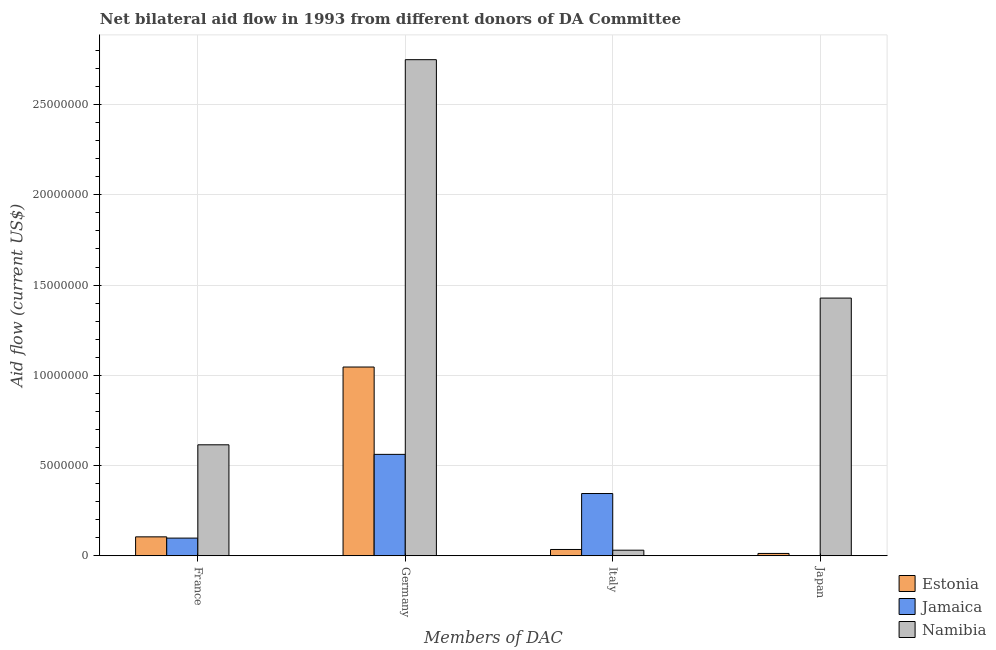How many different coloured bars are there?
Provide a short and direct response. 3. Are the number of bars per tick equal to the number of legend labels?
Offer a very short reply. No. Are the number of bars on each tick of the X-axis equal?
Your response must be concise. No. How many bars are there on the 2nd tick from the left?
Provide a succinct answer. 3. How many bars are there on the 1st tick from the right?
Ensure brevity in your answer.  2. What is the label of the 2nd group of bars from the left?
Your response must be concise. Germany. What is the amount of aid given by germany in Namibia?
Your response must be concise. 2.75e+07. Across all countries, what is the maximum amount of aid given by france?
Provide a succinct answer. 6.15e+06. Across all countries, what is the minimum amount of aid given by france?
Your response must be concise. 9.80e+05. In which country was the amount of aid given by japan maximum?
Your answer should be compact. Namibia. What is the total amount of aid given by germany in the graph?
Your answer should be very brief. 4.36e+07. What is the difference between the amount of aid given by france in Jamaica and that in Estonia?
Ensure brevity in your answer.  -7.00e+04. What is the difference between the amount of aid given by japan in Jamaica and the amount of aid given by germany in Estonia?
Provide a succinct answer. -1.05e+07. What is the average amount of aid given by france per country?
Make the answer very short. 2.73e+06. What is the difference between the amount of aid given by germany and amount of aid given by italy in Namibia?
Provide a short and direct response. 2.72e+07. In how many countries, is the amount of aid given by japan greater than 19000000 US$?
Keep it short and to the point. 0. What is the ratio of the amount of aid given by germany in Namibia to that in Estonia?
Keep it short and to the point. 2.63. Is the difference between the amount of aid given by italy in Jamaica and Namibia greater than the difference between the amount of aid given by france in Jamaica and Namibia?
Provide a short and direct response. Yes. What is the difference between the highest and the second highest amount of aid given by germany?
Your response must be concise. 1.70e+07. What is the difference between the highest and the lowest amount of aid given by france?
Provide a short and direct response. 5.17e+06. How many bars are there?
Provide a short and direct response. 11. How many countries are there in the graph?
Provide a succinct answer. 3. Does the graph contain any zero values?
Give a very brief answer. Yes. Does the graph contain grids?
Offer a very short reply. Yes. Where does the legend appear in the graph?
Your response must be concise. Bottom right. How many legend labels are there?
Provide a succinct answer. 3. How are the legend labels stacked?
Provide a short and direct response. Vertical. What is the title of the graph?
Give a very brief answer. Net bilateral aid flow in 1993 from different donors of DA Committee. Does "High income: nonOECD" appear as one of the legend labels in the graph?
Ensure brevity in your answer.  No. What is the label or title of the X-axis?
Your answer should be very brief. Members of DAC. What is the Aid flow (current US$) in Estonia in France?
Your response must be concise. 1.05e+06. What is the Aid flow (current US$) of Jamaica in France?
Provide a short and direct response. 9.80e+05. What is the Aid flow (current US$) of Namibia in France?
Offer a very short reply. 6.15e+06. What is the Aid flow (current US$) of Estonia in Germany?
Your answer should be compact. 1.05e+07. What is the Aid flow (current US$) of Jamaica in Germany?
Provide a succinct answer. 5.62e+06. What is the Aid flow (current US$) of Namibia in Germany?
Your answer should be compact. 2.75e+07. What is the Aid flow (current US$) in Jamaica in Italy?
Make the answer very short. 3.45e+06. What is the Aid flow (current US$) in Jamaica in Japan?
Your response must be concise. 0. What is the Aid flow (current US$) in Namibia in Japan?
Your answer should be very brief. 1.43e+07. Across all Members of DAC, what is the maximum Aid flow (current US$) of Estonia?
Your response must be concise. 1.05e+07. Across all Members of DAC, what is the maximum Aid flow (current US$) in Jamaica?
Your response must be concise. 5.62e+06. Across all Members of DAC, what is the maximum Aid flow (current US$) of Namibia?
Provide a succinct answer. 2.75e+07. Across all Members of DAC, what is the minimum Aid flow (current US$) of Namibia?
Your answer should be compact. 3.10e+05. What is the total Aid flow (current US$) of Estonia in the graph?
Keep it short and to the point. 1.20e+07. What is the total Aid flow (current US$) in Jamaica in the graph?
Offer a very short reply. 1.00e+07. What is the total Aid flow (current US$) of Namibia in the graph?
Provide a short and direct response. 4.82e+07. What is the difference between the Aid flow (current US$) in Estonia in France and that in Germany?
Offer a terse response. -9.41e+06. What is the difference between the Aid flow (current US$) of Jamaica in France and that in Germany?
Your response must be concise. -4.64e+06. What is the difference between the Aid flow (current US$) in Namibia in France and that in Germany?
Offer a very short reply. -2.13e+07. What is the difference between the Aid flow (current US$) of Jamaica in France and that in Italy?
Ensure brevity in your answer.  -2.47e+06. What is the difference between the Aid flow (current US$) in Namibia in France and that in Italy?
Provide a succinct answer. 5.84e+06. What is the difference between the Aid flow (current US$) of Estonia in France and that in Japan?
Your answer should be compact. 9.20e+05. What is the difference between the Aid flow (current US$) in Namibia in France and that in Japan?
Give a very brief answer. -8.13e+06. What is the difference between the Aid flow (current US$) in Estonia in Germany and that in Italy?
Offer a terse response. 1.01e+07. What is the difference between the Aid flow (current US$) in Jamaica in Germany and that in Italy?
Provide a short and direct response. 2.17e+06. What is the difference between the Aid flow (current US$) in Namibia in Germany and that in Italy?
Ensure brevity in your answer.  2.72e+07. What is the difference between the Aid flow (current US$) in Estonia in Germany and that in Japan?
Provide a succinct answer. 1.03e+07. What is the difference between the Aid flow (current US$) of Namibia in Germany and that in Japan?
Ensure brevity in your answer.  1.32e+07. What is the difference between the Aid flow (current US$) in Namibia in Italy and that in Japan?
Keep it short and to the point. -1.40e+07. What is the difference between the Aid flow (current US$) of Estonia in France and the Aid flow (current US$) of Jamaica in Germany?
Your answer should be compact. -4.57e+06. What is the difference between the Aid flow (current US$) in Estonia in France and the Aid flow (current US$) in Namibia in Germany?
Your answer should be very brief. -2.64e+07. What is the difference between the Aid flow (current US$) in Jamaica in France and the Aid flow (current US$) in Namibia in Germany?
Offer a terse response. -2.65e+07. What is the difference between the Aid flow (current US$) of Estonia in France and the Aid flow (current US$) of Jamaica in Italy?
Offer a terse response. -2.40e+06. What is the difference between the Aid flow (current US$) of Estonia in France and the Aid flow (current US$) of Namibia in Italy?
Offer a very short reply. 7.40e+05. What is the difference between the Aid flow (current US$) of Jamaica in France and the Aid flow (current US$) of Namibia in Italy?
Your response must be concise. 6.70e+05. What is the difference between the Aid flow (current US$) of Estonia in France and the Aid flow (current US$) of Namibia in Japan?
Offer a terse response. -1.32e+07. What is the difference between the Aid flow (current US$) in Jamaica in France and the Aid flow (current US$) in Namibia in Japan?
Keep it short and to the point. -1.33e+07. What is the difference between the Aid flow (current US$) in Estonia in Germany and the Aid flow (current US$) in Jamaica in Italy?
Offer a very short reply. 7.01e+06. What is the difference between the Aid flow (current US$) of Estonia in Germany and the Aid flow (current US$) of Namibia in Italy?
Your answer should be very brief. 1.02e+07. What is the difference between the Aid flow (current US$) of Jamaica in Germany and the Aid flow (current US$) of Namibia in Italy?
Your answer should be very brief. 5.31e+06. What is the difference between the Aid flow (current US$) in Estonia in Germany and the Aid flow (current US$) in Namibia in Japan?
Your answer should be very brief. -3.82e+06. What is the difference between the Aid flow (current US$) in Jamaica in Germany and the Aid flow (current US$) in Namibia in Japan?
Provide a succinct answer. -8.66e+06. What is the difference between the Aid flow (current US$) of Estonia in Italy and the Aid flow (current US$) of Namibia in Japan?
Provide a short and direct response. -1.39e+07. What is the difference between the Aid flow (current US$) of Jamaica in Italy and the Aid flow (current US$) of Namibia in Japan?
Your response must be concise. -1.08e+07. What is the average Aid flow (current US$) of Estonia per Members of DAC?
Your answer should be very brief. 3.00e+06. What is the average Aid flow (current US$) in Jamaica per Members of DAC?
Offer a very short reply. 2.51e+06. What is the average Aid flow (current US$) of Namibia per Members of DAC?
Provide a short and direct response. 1.21e+07. What is the difference between the Aid flow (current US$) of Estonia and Aid flow (current US$) of Namibia in France?
Provide a succinct answer. -5.10e+06. What is the difference between the Aid flow (current US$) in Jamaica and Aid flow (current US$) in Namibia in France?
Your response must be concise. -5.17e+06. What is the difference between the Aid flow (current US$) of Estonia and Aid flow (current US$) of Jamaica in Germany?
Ensure brevity in your answer.  4.84e+06. What is the difference between the Aid flow (current US$) of Estonia and Aid flow (current US$) of Namibia in Germany?
Give a very brief answer. -1.70e+07. What is the difference between the Aid flow (current US$) in Jamaica and Aid flow (current US$) in Namibia in Germany?
Your answer should be very brief. -2.19e+07. What is the difference between the Aid flow (current US$) of Estonia and Aid flow (current US$) of Jamaica in Italy?
Your answer should be compact. -3.10e+06. What is the difference between the Aid flow (current US$) of Jamaica and Aid flow (current US$) of Namibia in Italy?
Offer a terse response. 3.14e+06. What is the difference between the Aid flow (current US$) in Estonia and Aid flow (current US$) in Namibia in Japan?
Offer a very short reply. -1.42e+07. What is the ratio of the Aid flow (current US$) of Estonia in France to that in Germany?
Your answer should be compact. 0.1. What is the ratio of the Aid flow (current US$) in Jamaica in France to that in Germany?
Make the answer very short. 0.17. What is the ratio of the Aid flow (current US$) in Namibia in France to that in Germany?
Your response must be concise. 0.22. What is the ratio of the Aid flow (current US$) of Estonia in France to that in Italy?
Your answer should be compact. 3. What is the ratio of the Aid flow (current US$) in Jamaica in France to that in Italy?
Keep it short and to the point. 0.28. What is the ratio of the Aid flow (current US$) in Namibia in France to that in Italy?
Your answer should be compact. 19.84. What is the ratio of the Aid flow (current US$) of Estonia in France to that in Japan?
Give a very brief answer. 8.08. What is the ratio of the Aid flow (current US$) in Namibia in France to that in Japan?
Give a very brief answer. 0.43. What is the ratio of the Aid flow (current US$) in Estonia in Germany to that in Italy?
Provide a succinct answer. 29.89. What is the ratio of the Aid flow (current US$) in Jamaica in Germany to that in Italy?
Make the answer very short. 1.63. What is the ratio of the Aid flow (current US$) of Namibia in Germany to that in Italy?
Ensure brevity in your answer.  88.68. What is the ratio of the Aid flow (current US$) in Estonia in Germany to that in Japan?
Your answer should be very brief. 80.46. What is the ratio of the Aid flow (current US$) in Namibia in Germany to that in Japan?
Provide a short and direct response. 1.93. What is the ratio of the Aid flow (current US$) in Estonia in Italy to that in Japan?
Make the answer very short. 2.69. What is the ratio of the Aid flow (current US$) in Namibia in Italy to that in Japan?
Make the answer very short. 0.02. What is the difference between the highest and the second highest Aid flow (current US$) in Estonia?
Ensure brevity in your answer.  9.41e+06. What is the difference between the highest and the second highest Aid flow (current US$) of Jamaica?
Offer a very short reply. 2.17e+06. What is the difference between the highest and the second highest Aid flow (current US$) of Namibia?
Keep it short and to the point. 1.32e+07. What is the difference between the highest and the lowest Aid flow (current US$) of Estonia?
Your answer should be compact. 1.03e+07. What is the difference between the highest and the lowest Aid flow (current US$) of Jamaica?
Ensure brevity in your answer.  5.62e+06. What is the difference between the highest and the lowest Aid flow (current US$) in Namibia?
Give a very brief answer. 2.72e+07. 